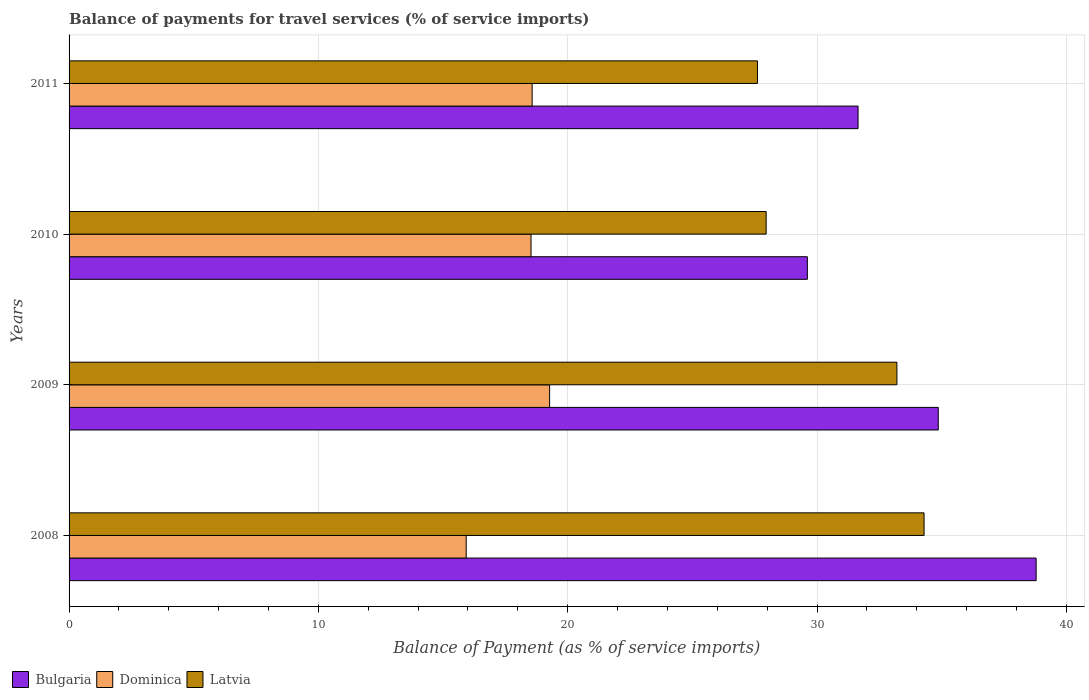How many different coloured bars are there?
Offer a terse response. 3. How many bars are there on the 2nd tick from the bottom?
Provide a short and direct response. 3. What is the label of the 3rd group of bars from the top?
Your response must be concise. 2009. What is the balance of payments for travel services in Bulgaria in 2010?
Your response must be concise. 29.61. Across all years, what is the maximum balance of payments for travel services in Latvia?
Keep it short and to the point. 34.29. Across all years, what is the minimum balance of payments for travel services in Bulgaria?
Provide a short and direct response. 29.61. In which year was the balance of payments for travel services in Dominica minimum?
Provide a succinct answer. 2008. What is the total balance of payments for travel services in Bulgaria in the graph?
Ensure brevity in your answer.  134.91. What is the difference between the balance of payments for travel services in Bulgaria in 2010 and that in 2011?
Your answer should be very brief. -2.03. What is the difference between the balance of payments for travel services in Dominica in 2010 and the balance of payments for travel services in Bulgaria in 2011?
Keep it short and to the point. -13.12. What is the average balance of payments for travel services in Dominica per year?
Your answer should be compact. 18.08. In the year 2008, what is the difference between the balance of payments for travel services in Latvia and balance of payments for travel services in Bulgaria?
Ensure brevity in your answer.  -4.5. What is the ratio of the balance of payments for travel services in Dominica in 2008 to that in 2009?
Give a very brief answer. 0.83. Is the balance of payments for travel services in Latvia in 2008 less than that in 2011?
Ensure brevity in your answer.  No. Is the difference between the balance of payments for travel services in Latvia in 2009 and 2011 greater than the difference between the balance of payments for travel services in Bulgaria in 2009 and 2011?
Offer a terse response. Yes. What is the difference between the highest and the second highest balance of payments for travel services in Latvia?
Your response must be concise. 1.09. What is the difference between the highest and the lowest balance of payments for travel services in Dominica?
Provide a short and direct response. 3.35. In how many years, is the balance of payments for travel services in Latvia greater than the average balance of payments for travel services in Latvia taken over all years?
Ensure brevity in your answer.  2. What does the 1st bar from the top in 2011 represents?
Give a very brief answer. Latvia. What does the 3rd bar from the bottom in 2010 represents?
Your answer should be very brief. Latvia. Is it the case that in every year, the sum of the balance of payments for travel services in Dominica and balance of payments for travel services in Bulgaria is greater than the balance of payments for travel services in Latvia?
Ensure brevity in your answer.  Yes. How many bars are there?
Offer a terse response. 12. How many years are there in the graph?
Your answer should be very brief. 4. Does the graph contain any zero values?
Your response must be concise. No. Does the graph contain grids?
Ensure brevity in your answer.  Yes. What is the title of the graph?
Make the answer very short. Balance of payments for travel services (% of service imports). What is the label or title of the X-axis?
Keep it short and to the point. Balance of Payment (as % of service imports). What is the Balance of Payment (as % of service imports) of Bulgaria in 2008?
Offer a terse response. 38.79. What is the Balance of Payment (as % of service imports) of Dominica in 2008?
Provide a short and direct response. 15.93. What is the Balance of Payment (as % of service imports) of Latvia in 2008?
Your answer should be very brief. 34.29. What is the Balance of Payment (as % of service imports) in Bulgaria in 2009?
Give a very brief answer. 34.86. What is the Balance of Payment (as % of service imports) of Dominica in 2009?
Your answer should be compact. 19.27. What is the Balance of Payment (as % of service imports) of Latvia in 2009?
Provide a succinct answer. 33.2. What is the Balance of Payment (as % of service imports) in Bulgaria in 2010?
Give a very brief answer. 29.61. What is the Balance of Payment (as % of service imports) in Dominica in 2010?
Make the answer very short. 18.53. What is the Balance of Payment (as % of service imports) of Latvia in 2010?
Ensure brevity in your answer.  27.96. What is the Balance of Payment (as % of service imports) in Bulgaria in 2011?
Your answer should be very brief. 31.65. What is the Balance of Payment (as % of service imports) of Dominica in 2011?
Keep it short and to the point. 18.57. What is the Balance of Payment (as % of service imports) in Latvia in 2011?
Your answer should be very brief. 27.61. Across all years, what is the maximum Balance of Payment (as % of service imports) of Bulgaria?
Your answer should be very brief. 38.79. Across all years, what is the maximum Balance of Payment (as % of service imports) in Dominica?
Your response must be concise. 19.27. Across all years, what is the maximum Balance of Payment (as % of service imports) in Latvia?
Your response must be concise. 34.29. Across all years, what is the minimum Balance of Payment (as % of service imports) in Bulgaria?
Give a very brief answer. 29.61. Across all years, what is the minimum Balance of Payment (as % of service imports) in Dominica?
Give a very brief answer. 15.93. Across all years, what is the minimum Balance of Payment (as % of service imports) of Latvia?
Make the answer very short. 27.61. What is the total Balance of Payment (as % of service imports) of Bulgaria in the graph?
Give a very brief answer. 134.91. What is the total Balance of Payment (as % of service imports) of Dominica in the graph?
Offer a very short reply. 72.3. What is the total Balance of Payment (as % of service imports) of Latvia in the graph?
Keep it short and to the point. 123.07. What is the difference between the Balance of Payment (as % of service imports) of Bulgaria in 2008 and that in 2009?
Keep it short and to the point. 3.93. What is the difference between the Balance of Payment (as % of service imports) in Dominica in 2008 and that in 2009?
Offer a very short reply. -3.35. What is the difference between the Balance of Payment (as % of service imports) of Latvia in 2008 and that in 2009?
Your response must be concise. 1.09. What is the difference between the Balance of Payment (as % of service imports) in Bulgaria in 2008 and that in 2010?
Make the answer very short. 9.18. What is the difference between the Balance of Payment (as % of service imports) in Dominica in 2008 and that in 2010?
Offer a very short reply. -2.6. What is the difference between the Balance of Payment (as % of service imports) of Latvia in 2008 and that in 2010?
Provide a short and direct response. 6.33. What is the difference between the Balance of Payment (as % of service imports) of Bulgaria in 2008 and that in 2011?
Provide a short and direct response. 7.14. What is the difference between the Balance of Payment (as % of service imports) in Dominica in 2008 and that in 2011?
Ensure brevity in your answer.  -2.64. What is the difference between the Balance of Payment (as % of service imports) of Latvia in 2008 and that in 2011?
Ensure brevity in your answer.  6.68. What is the difference between the Balance of Payment (as % of service imports) in Bulgaria in 2009 and that in 2010?
Make the answer very short. 5.25. What is the difference between the Balance of Payment (as % of service imports) of Dominica in 2009 and that in 2010?
Offer a terse response. 0.75. What is the difference between the Balance of Payment (as % of service imports) of Latvia in 2009 and that in 2010?
Give a very brief answer. 5.24. What is the difference between the Balance of Payment (as % of service imports) of Bulgaria in 2009 and that in 2011?
Provide a short and direct response. 3.22. What is the difference between the Balance of Payment (as % of service imports) of Dominica in 2009 and that in 2011?
Your response must be concise. 0.7. What is the difference between the Balance of Payment (as % of service imports) in Latvia in 2009 and that in 2011?
Provide a succinct answer. 5.59. What is the difference between the Balance of Payment (as % of service imports) in Bulgaria in 2010 and that in 2011?
Your response must be concise. -2.03. What is the difference between the Balance of Payment (as % of service imports) of Dominica in 2010 and that in 2011?
Provide a short and direct response. -0.04. What is the difference between the Balance of Payment (as % of service imports) of Latvia in 2010 and that in 2011?
Keep it short and to the point. 0.35. What is the difference between the Balance of Payment (as % of service imports) of Bulgaria in 2008 and the Balance of Payment (as % of service imports) of Dominica in 2009?
Offer a very short reply. 19.51. What is the difference between the Balance of Payment (as % of service imports) in Bulgaria in 2008 and the Balance of Payment (as % of service imports) in Latvia in 2009?
Provide a short and direct response. 5.58. What is the difference between the Balance of Payment (as % of service imports) of Dominica in 2008 and the Balance of Payment (as % of service imports) of Latvia in 2009?
Your response must be concise. -17.27. What is the difference between the Balance of Payment (as % of service imports) of Bulgaria in 2008 and the Balance of Payment (as % of service imports) of Dominica in 2010?
Your answer should be compact. 20.26. What is the difference between the Balance of Payment (as % of service imports) of Bulgaria in 2008 and the Balance of Payment (as % of service imports) of Latvia in 2010?
Provide a short and direct response. 10.83. What is the difference between the Balance of Payment (as % of service imports) of Dominica in 2008 and the Balance of Payment (as % of service imports) of Latvia in 2010?
Provide a short and direct response. -12.03. What is the difference between the Balance of Payment (as % of service imports) in Bulgaria in 2008 and the Balance of Payment (as % of service imports) in Dominica in 2011?
Your answer should be compact. 20.21. What is the difference between the Balance of Payment (as % of service imports) in Bulgaria in 2008 and the Balance of Payment (as % of service imports) in Latvia in 2011?
Offer a terse response. 11.18. What is the difference between the Balance of Payment (as % of service imports) of Dominica in 2008 and the Balance of Payment (as % of service imports) of Latvia in 2011?
Your answer should be very brief. -11.68. What is the difference between the Balance of Payment (as % of service imports) in Bulgaria in 2009 and the Balance of Payment (as % of service imports) in Dominica in 2010?
Offer a very short reply. 16.33. What is the difference between the Balance of Payment (as % of service imports) of Bulgaria in 2009 and the Balance of Payment (as % of service imports) of Latvia in 2010?
Give a very brief answer. 6.9. What is the difference between the Balance of Payment (as % of service imports) of Dominica in 2009 and the Balance of Payment (as % of service imports) of Latvia in 2010?
Give a very brief answer. -8.69. What is the difference between the Balance of Payment (as % of service imports) in Bulgaria in 2009 and the Balance of Payment (as % of service imports) in Dominica in 2011?
Offer a very short reply. 16.29. What is the difference between the Balance of Payment (as % of service imports) of Bulgaria in 2009 and the Balance of Payment (as % of service imports) of Latvia in 2011?
Give a very brief answer. 7.25. What is the difference between the Balance of Payment (as % of service imports) in Dominica in 2009 and the Balance of Payment (as % of service imports) in Latvia in 2011?
Offer a very short reply. -8.34. What is the difference between the Balance of Payment (as % of service imports) of Bulgaria in 2010 and the Balance of Payment (as % of service imports) of Dominica in 2011?
Provide a short and direct response. 11.04. What is the difference between the Balance of Payment (as % of service imports) in Bulgaria in 2010 and the Balance of Payment (as % of service imports) in Latvia in 2011?
Your answer should be very brief. 2. What is the difference between the Balance of Payment (as % of service imports) in Dominica in 2010 and the Balance of Payment (as % of service imports) in Latvia in 2011?
Keep it short and to the point. -9.08. What is the average Balance of Payment (as % of service imports) in Bulgaria per year?
Offer a very short reply. 33.73. What is the average Balance of Payment (as % of service imports) of Dominica per year?
Provide a succinct answer. 18.08. What is the average Balance of Payment (as % of service imports) in Latvia per year?
Give a very brief answer. 30.77. In the year 2008, what is the difference between the Balance of Payment (as % of service imports) of Bulgaria and Balance of Payment (as % of service imports) of Dominica?
Ensure brevity in your answer.  22.86. In the year 2008, what is the difference between the Balance of Payment (as % of service imports) in Bulgaria and Balance of Payment (as % of service imports) in Latvia?
Your response must be concise. 4.5. In the year 2008, what is the difference between the Balance of Payment (as % of service imports) in Dominica and Balance of Payment (as % of service imports) in Latvia?
Offer a terse response. -18.36. In the year 2009, what is the difference between the Balance of Payment (as % of service imports) in Bulgaria and Balance of Payment (as % of service imports) in Dominica?
Your response must be concise. 15.59. In the year 2009, what is the difference between the Balance of Payment (as % of service imports) of Bulgaria and Balance of Payment (as % of service imports) of Latvia?
Offer a very short reply. 1.66. In the year 2009, what is the difference between the Balance of Payment (as % of service imports) of Dominica and Balance of Payment (as % of service imports) of Latvia?
Provide a short and direct response. -13.93. In the year 2010, what is the difference between the Balance of Payment (as % of service imports) in Bulgaria and Balance of Payment (as % of service imports) in Dominica?
Provide a short and direct response. 11.08. In the year 2010, what is the difference between the Balance of Payment (as % of service imports) of Bulgaria and Balance of Payment (as % of service imports) of Latvia?
Make the answer very short. 1.65. In the year 2010, what is the difference between the Balance of Payment (as % of service imports) of Dominica and Balance of Payment (as % of service imports) of Latvia?
Offer a very short reply. -9.43. In the year 2011, what is the difference between the Balance of Payment (as % of service imports) in Bulgaria and Balance of Payment (as % of service imports) in Dominica?
Offer a terse response. 13.07. In the year 2011, what is the difference between the Balance of Payment (as % of service imports) of Bulgaria and Balance of Payment (as % of service imports) of Latvia?
Your answer should be very brief. 4.03. In the year 2011, what is the difference between the Balance of Payment (as % of service imports) in Dominica and Balance of Payment (as % of service imports) in Latvia?
Provide a short and direct response. -9.04. What is the ratio of the Balance of Payment (as % of service imports) in Bulgaria in 2008 to that in 2009?
Provide a short and direct response. 1.11. What is the ratio of the Balance of Payment (as % of service imports) of Dominica in 2008 to that in 2009?
Provide a succinct answer. 0.83. What is the ratio of the Balance of Payment (as % of service imports) of Latvia in 2008 to that in 2009?
Offer a terse response. 1.03. What is the ratio of the Balance of Payment (as % of service imports) in Bulgaria in 2008 to that in 2010?
Offer a very short reply. 1.31. What is the ratio of the Balance of Payment (as % of service imports) of Dominica in 2008 to that in 2010?
Keep it short and to the point. 0.86. What is the ratio of the Balance of Payment (as % of service imports) in Latvia in 2008 to that in 2010?
Offer a terse response. 1.23. What is the ratio of the Balance of Payment (as % of service imports) of Bulgaria in 2008 to that in 2011?
Give a very brief answer. 1.23. What is the ratio of the Balance of Payment (as % of service imports) of Dominica in 2008 to that in 2011?
Your response must be concise. 0.86. What is the ratio of the Balance of Payment (as % of service imports) in Latvia in 2008 to that in 2011?
Your answer should be very brief. 1.24. What is the ratio of the Balance of Payment (as % of service imports) in Bulgaria in 2009 to that in 2010?
Keep it short and to the point. 1.18. What is the ratio of the Balance of Payment (as % of service imports) of Dominica in 2009 to that in 2010?
Your response must be concise. 1.04. What is the ratio of the Balance of Payment (as % of service imports) in Latvia in 2009 to that in 2010?
Your response must be concise. 1.19. What is the ratio of the Balance of Payment (as % of service imports) of Bulgaria in 2009 to that in 2011?
Offer a terse response. 1.1. What is the ratio of the Balance of Payment (as % of service imports) of Dominica in 2009 to that in 2011?
Your answer should be compact. 1.04. What is the ratio of the Balance of Payment (as % of service imports) of Latvia in 2009 to that in 2011?
Ensure brevity in your answer.  1.2. What is the ratio of the Balance of Payment (as % of service imports) of Bulgaria in 2010 to that in 2011?
Keep it short and to the point. 0.94. What is the ratio of the Balance of Payment (as % of service imports) in Dominica in 2010 to that in 2011?
Your answer should be compact. 1. What is the ratio of the Balance of Payment (as % of service imports) of Latvia in 2010 to that in 2011?
Ensure brevity in your answer.  1.01. What is the difference between the highest and the second highest Balance of Payment (as % of service imports) of Bulgaria?
Ensure brevity in your answer.  3.93. What is the difference between the highest and the second highest Balance of Payment (as % of service imports) in Dominica?
Offer a very short reply. 0.7. What is the difference between the highest and the second highest Balance of Payment (as % of service imports) of Latvia?
Provide a succinct answer. 1.09. What is the difference between the highest and the lowest Balance of Payment (as % of service imports) in Bulgaria?
Your response must be concise. 9.18. What is the difference between the highest and the lowest Balance of Payment (as % of service imports) of Dominica?
Ensure brevity in your answer.  3.35. What is the difference between the highest and the lowest Balance of Payment (as % of service imports) in Latvia?
Your answer should be compact. 6.68. 